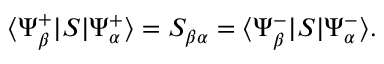<formula> <loc_0><loc_0><loc_500><loc_500>\langle \Psi _ { \beta } ^ { + } | S | \Psi _ { \alpha } ^ { + } \rangle = S _ { \beta \alpha } = \langle \Psi _ { \beta } ^ { - } | S | \Psi _ { \alpha } ^ { - } \rangle .</formula> 